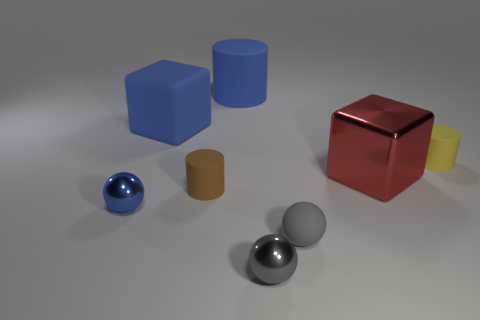There is a tiny gray shiny thing; are there any tiny brown rubber cylinders in front of it?
Provide a short and direct response. No. Is the shape of the large red object that is in front of the yellow rubber thing the same as the blue object that is in front of the tiny yellow matte object?
Your answer should be compact. No. How many things are blue metallic balls or tiny shiny objects that are behind the gray rubber sphere?
Your answer should be compact. 1. How many other objects are there of the same shape as the large shiny thing?
Provide a short and direct response. 1. Do the small blue object on the left side of the small brown cylinder and the red block have the same material?
Make the answer very short. Yes. How many things are large blue shiny blocks or small yellow rubber cylinders?
Keep it short and to the point. 1. What size is the other gray thing that is the same shape as the gray matte thing?
Ensure brevity in your answer.  Small. The blue sphere has what size?
Give a very brief answer. Small. Are there more big red shiny things that are left of the big red block than blue matte cylinders?
Ensure brevity in your answer.  No. Is there any other thing that is the same material as the tiny brown thing?
Ensure brevity in your answer.  Yes. 